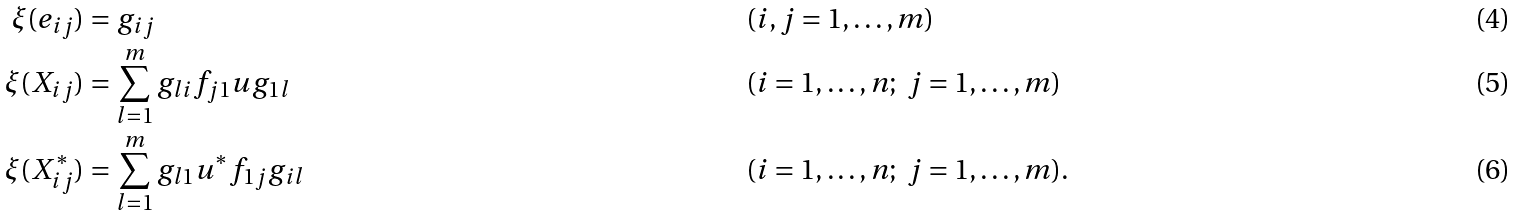<formula> <loc_0><loc_0><loc_500><loc_500>\xi ( e _ { i j } ) & = g _ { i j } & & ( i , j = 1 , \dots , m ) \\ \xi ( X _ { i j } ) & = \sum _ { l = 1 } ^ { m } g _ { l i } f _ { j 1 } u g _ { 1 l } & & ( i = 1 , \dots , n ; \ j = 1 , \dots , m ) \\ \xi ( X ^ { * } _ { i j } ) & = \sum _ { l = 1 } ^ { m } g _ { l 1 } u ^ { * } f _ { 1 j } g _ { i l } & & ( i = 1 , \dots , n ; \ j = 1 , \dots , m ) .</formula> 